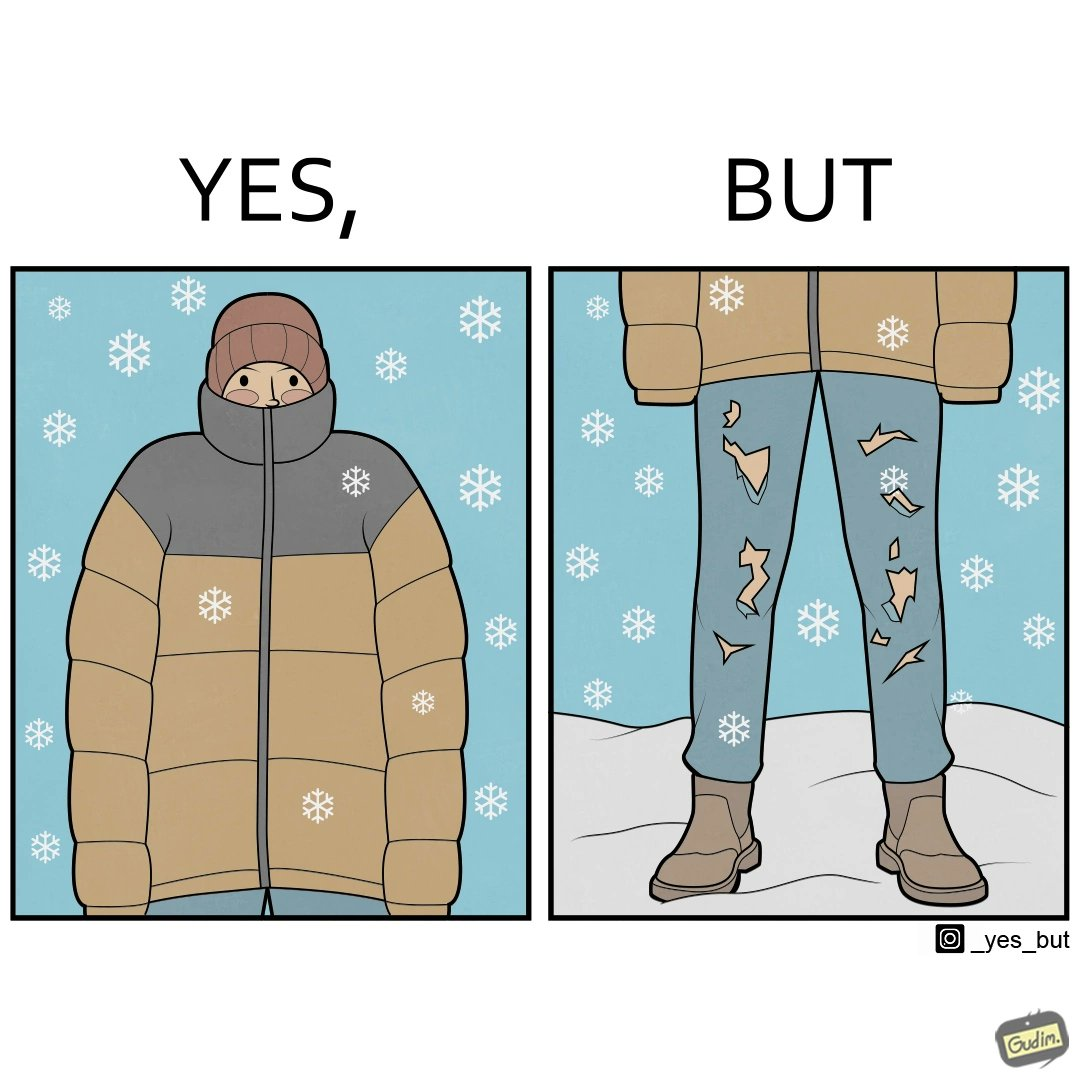What makes this image funny or satirical? This is funny because on the one hand this person is feeling very cold and has his jacket all the way up to his face, but on the other hand his trousers are torn which kind of makes the jacket redundant. 